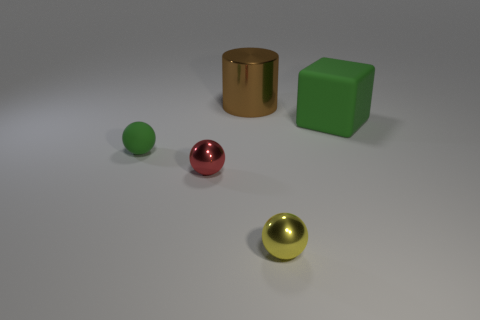What shape is the rubber object that is on the left side of the big object in front of the big brown object? The rubber object on the left side of the cylinder, which is in front of the large brown object, is a small, round green sphere, possibly a ball. 